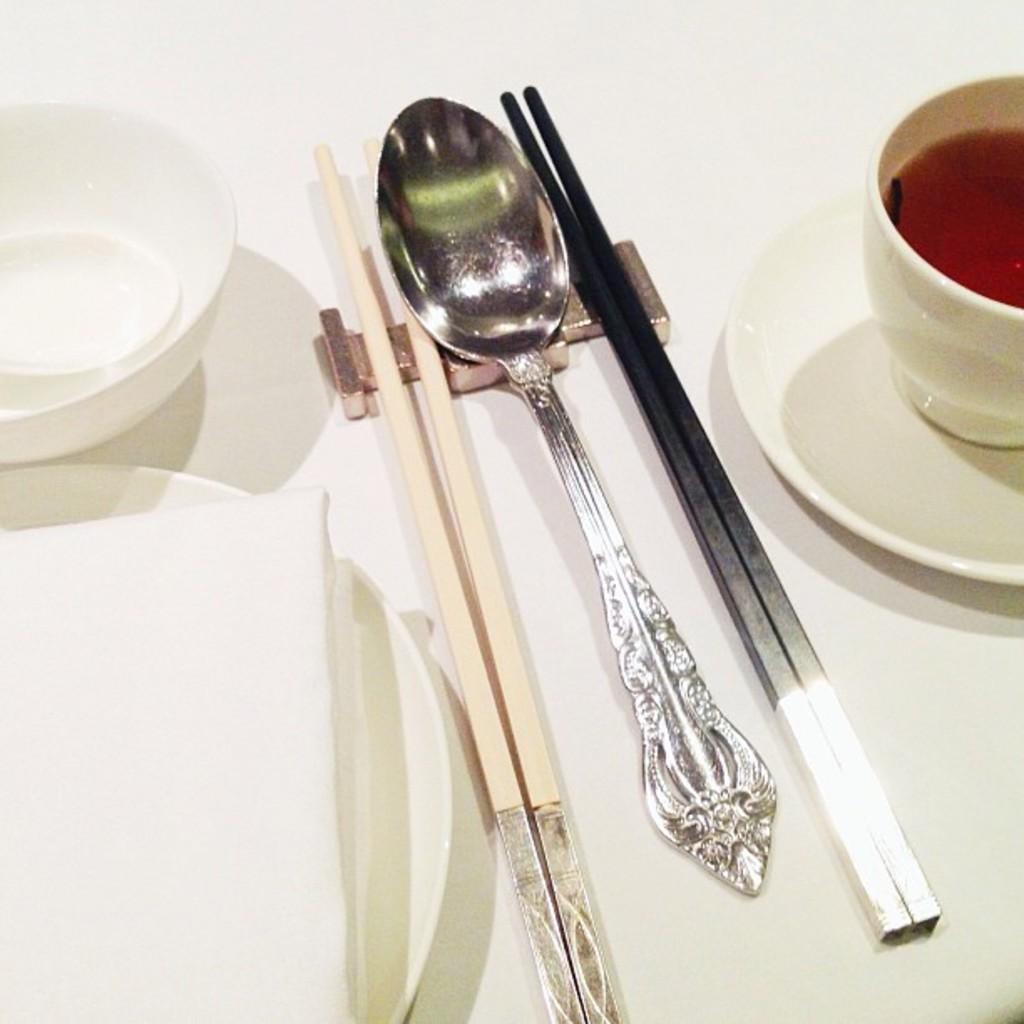Could you give a brief overview of what you see in this image? In the image we can see there is a table on which there are chopsticks, spoon and in a cup there is a soup. 